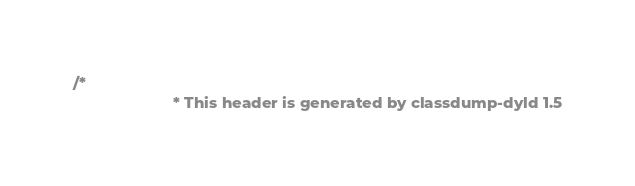Convert code to text. <code><loc_0><loc_0><loc_500><loc_500><_C_>/*
                       * This header is generated by classdump-dyld 1.5</code> 